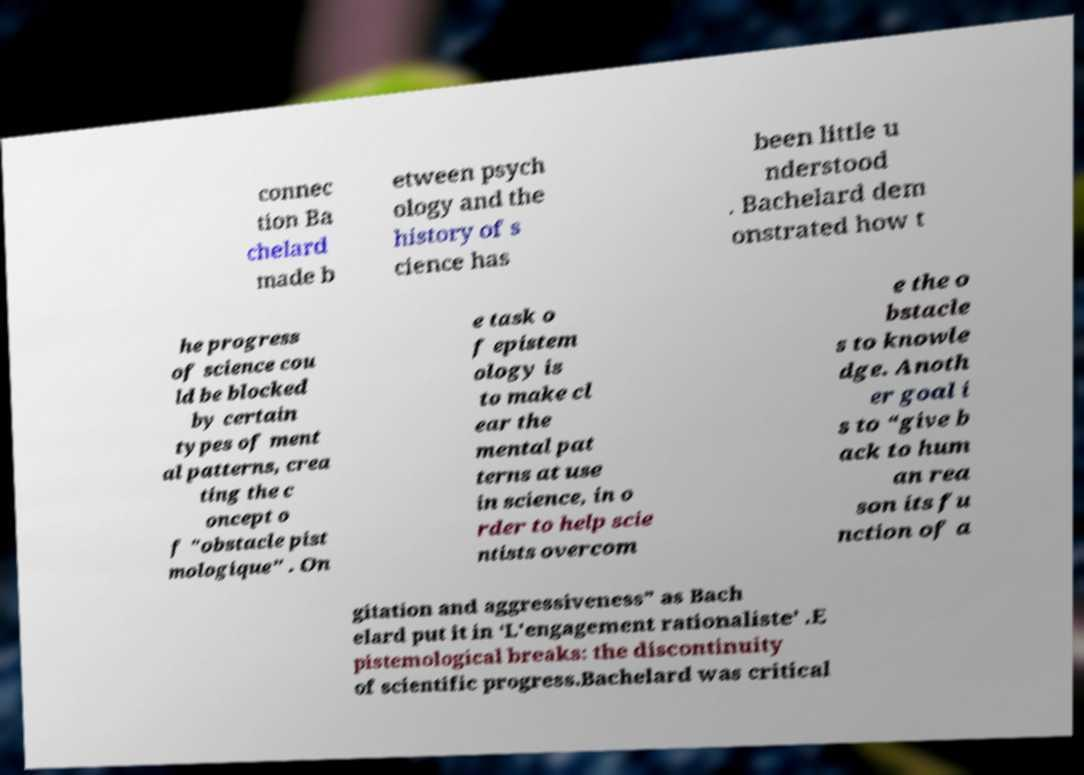For documentation purposes, I need the text within this image transcribed. Could you provide that? connec tion Ba chelard made b etween psych ology and the history of s cience has been little u nderstood . Bachelard dem onstrated how t he progress of science cou ld be blocked by certain types of ment al patterns, crea ting the c oncept o f "obstacle pist mologique" . On e task o f epistem ology is to make cl ear the mental pat terns at use in science, in o rder to help scie ntists overcom e the o bstacle s to knowle dge. Anoth er goal i s to “give b ack to hum an rea son its fu nction of a gitation and aggressiveness” as Bach elard put it in ‘L'engagement rationaliste’ .E pistemological breaks: the discontinuity of scientific progress.Bachelard was critical 